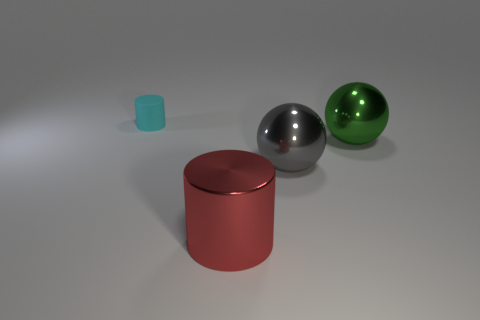What is the size of the thing that is to the left of the cylinder that is right of the tiny object?
Give a very brief answer. Small. What is the shape of the rubber thing?
Offer a terse response. Cylinder. There is a cylinder behind the green sphere; what is it made of?
Your answer should be very brief. Rubber. What is the color of the cylinder that is behind the cylinder that is in front of the cylinder behind the red cylinder?
Provide a short and direct response. Cyan. The other shiny ball that is the same size as the gray ball is what color?
Give a very brief answer. Green. How many matte objects are either large red objects or spheres?
Your answer should be very brief. 0. There is a sphere that is the same material as the large gray object; what color is it?
Give a very brief answer. Green. What material is the cylinder that is behind the shiny ball in front of the big green ball made of?
Your answer should be very brief. Rubber. What number of objects are either objects that are right of the matte object or objects that are in front of the green object?
Keep it short and to the point. 3. There is a cylinder that is on the right side of the cylinder left of the cylinder in front of the matte cylinder; how big is it?
Your answer should be compact. Large. 